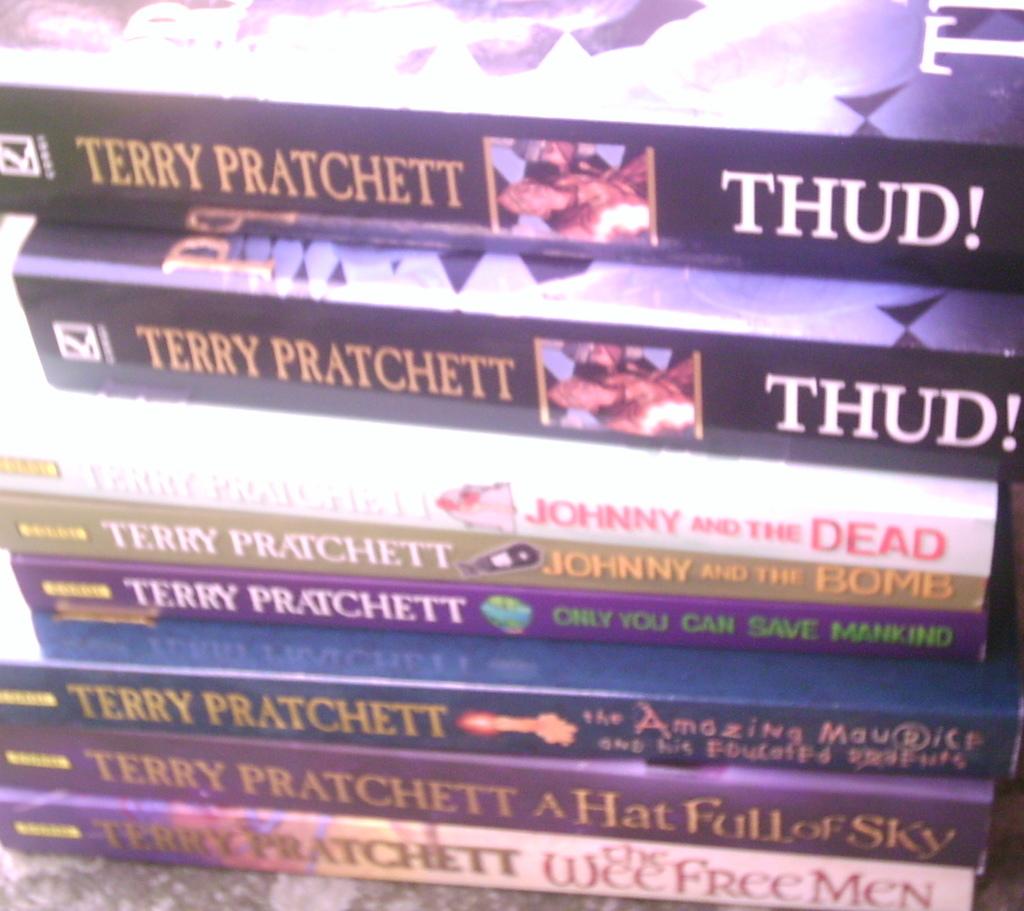All the books are written by whom?
Make the answer very short. Terry pratchett. What is the title of the top book?
Provide a short and direct response. Thud!. 